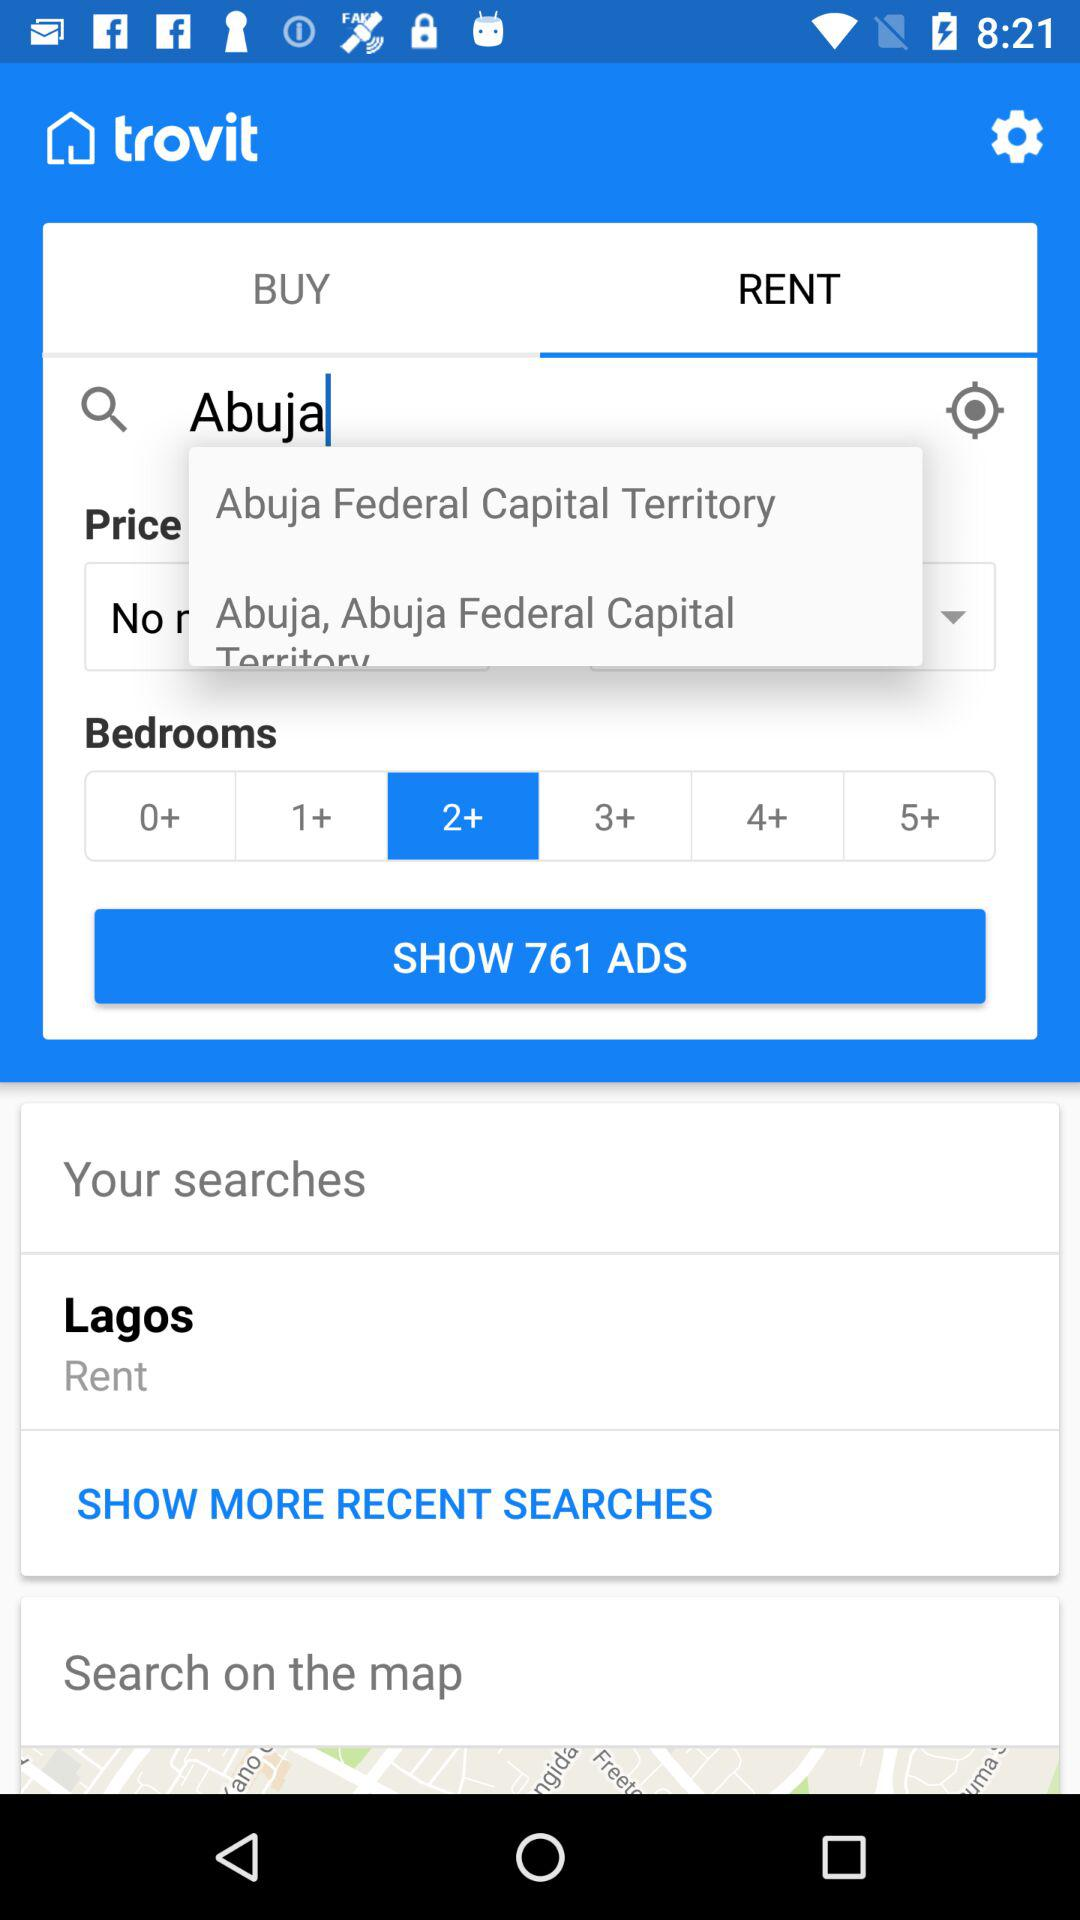How many advertisements are there? There are 761 advertisements. 